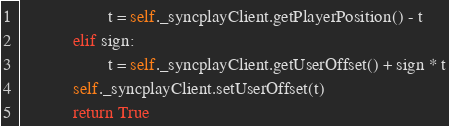Convert code to text. <code><loc_0><loc_0><loc_500><loc_500><_Python_>                    t = self._syncplayClient.getPlayerPosition() - t
            elif sign:
                    t = self._syncplayClient.getUserOffset() + sign * t
            self._syncplayClient.setUserOffset(t)
            return True</code> 